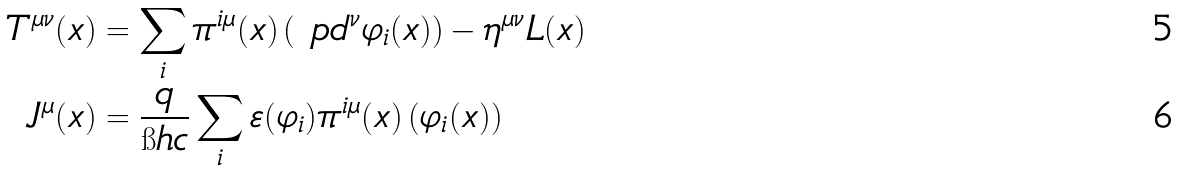<formula> <loc_0><loc_0><loc_500><loc_500>T ^ { \mu \nu } ( x ) & = \sum _ { i } \pi ^ { i \mu } ( x ) \left ( \ p d ^ { \nu } \varphi _ { i } ( x ) \right ) - \eta ^ { \mu \nu } L ( x ) \\ J ^ { \mu } ( x ) & = \frac { q } { \i h c } \sum _ { i } \varepsilon ( \varphi _ { i } ) \pi ^ { i \mu } ( x ) \left ( \varphi _ { i } ( x ) \right )</formula> 